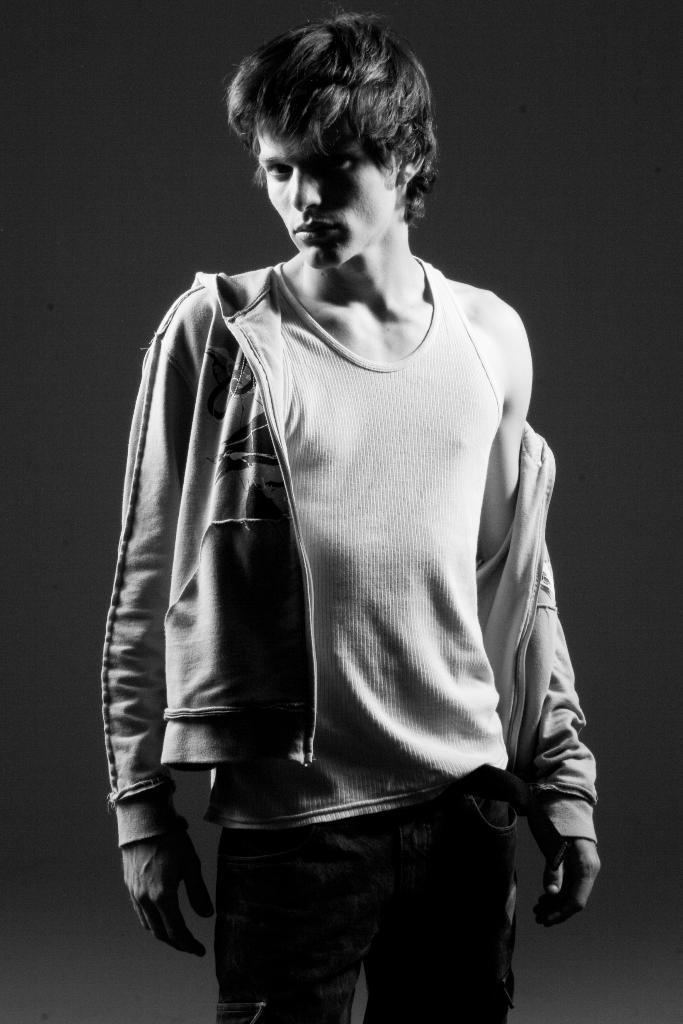Who is present in the image? There is a man in the image. What is the man doing in the image? The man is standing in the image. What is the man wearing in the image? The man is wearing a coat in the image. What can be seen in the background of the image? The backdrop of the image is dark. What type of salt is being used to create the art in the image? There is no salt or art present in the image; it features a man standing with a dark backdrop. 